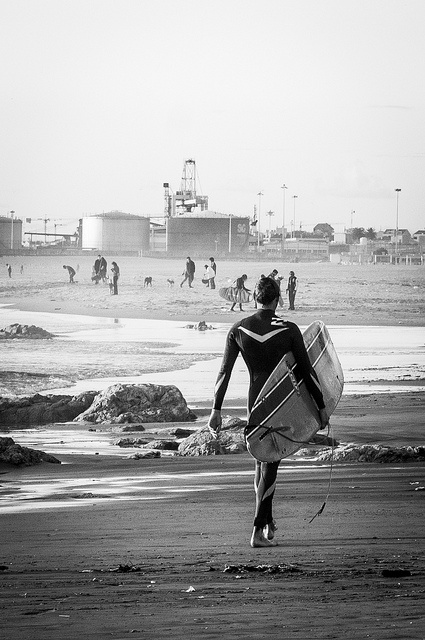Describe the objects in this image and their specific colors. I can see people in white, black, gray, darkgray, and lightgray tones, surfboard in white, gray, black, darkgray, and lightgray tones, surfboard in white, darkgray, gray, lightgray, and black tones, people in white, gray, black, darkgray, and lightgray tones, and people in white, gray, darkgray, lightgray, and black tones in this image. 